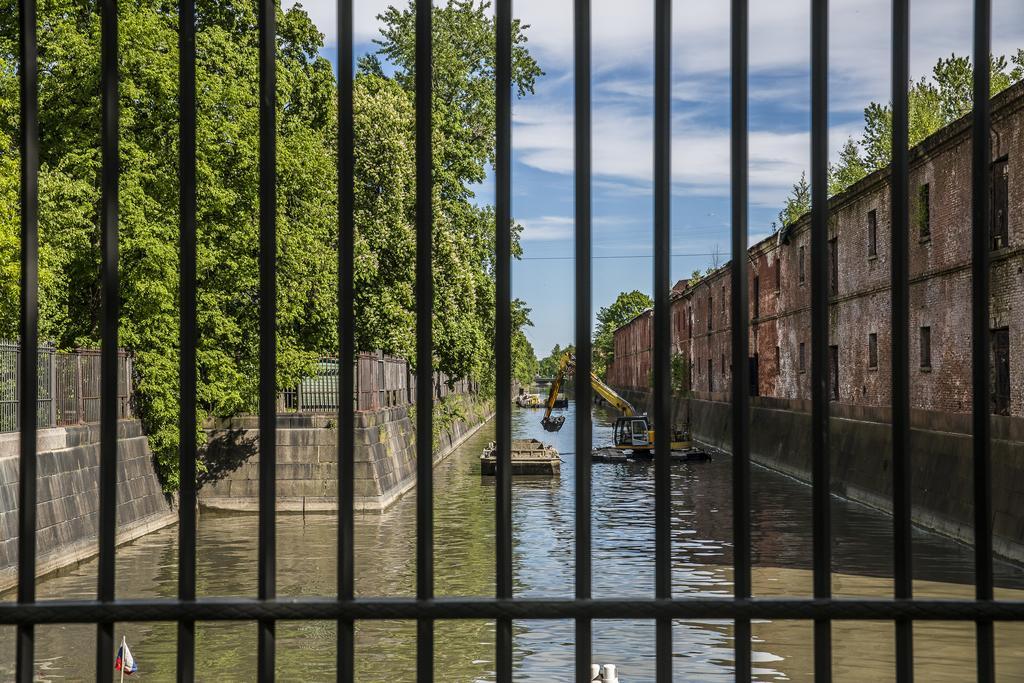Could you give a brief overview of what you see in this image? The image is captured from behind a fence and there is a river and on the river there is a crane and few boats, the river is in between the walls and around the walls there are plenty of trees. 